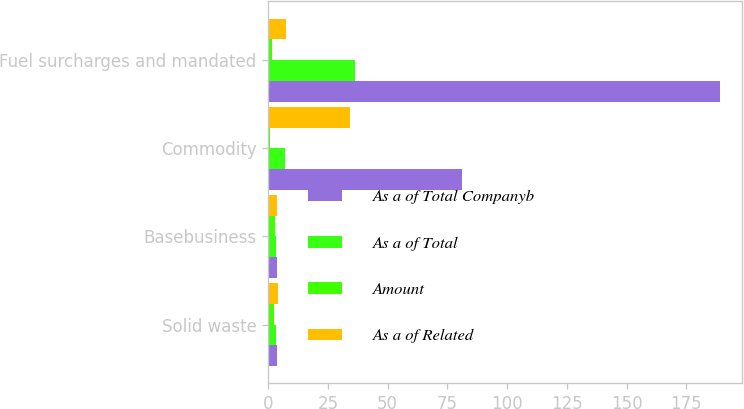Convert chart. <chart><loc_0><loc_0><loc_500><loc_500><stacked_bar_chart><ecel><fcel>Solid waste<fcel>Basebusiness<fcel>Commodity<fcel>Fuel surcharges and mandated<nl><fcel>As a of Total Companyb<fcel>3.85<fcel>3.85<fcel>81<fcel>189<nl><fcel>As a of Total<fcel>3.2<fcel>3.2<fcel>6.9<fcel>36.5<nl><fcel>Amount<fcel>2.6<fcel>2.8<fcel>0.6<fcel>1.4<nl><fcel>As a of Related<fcel>4<fcel>3.7<fcel>34.3<fcel>7.3<nl></chart> 